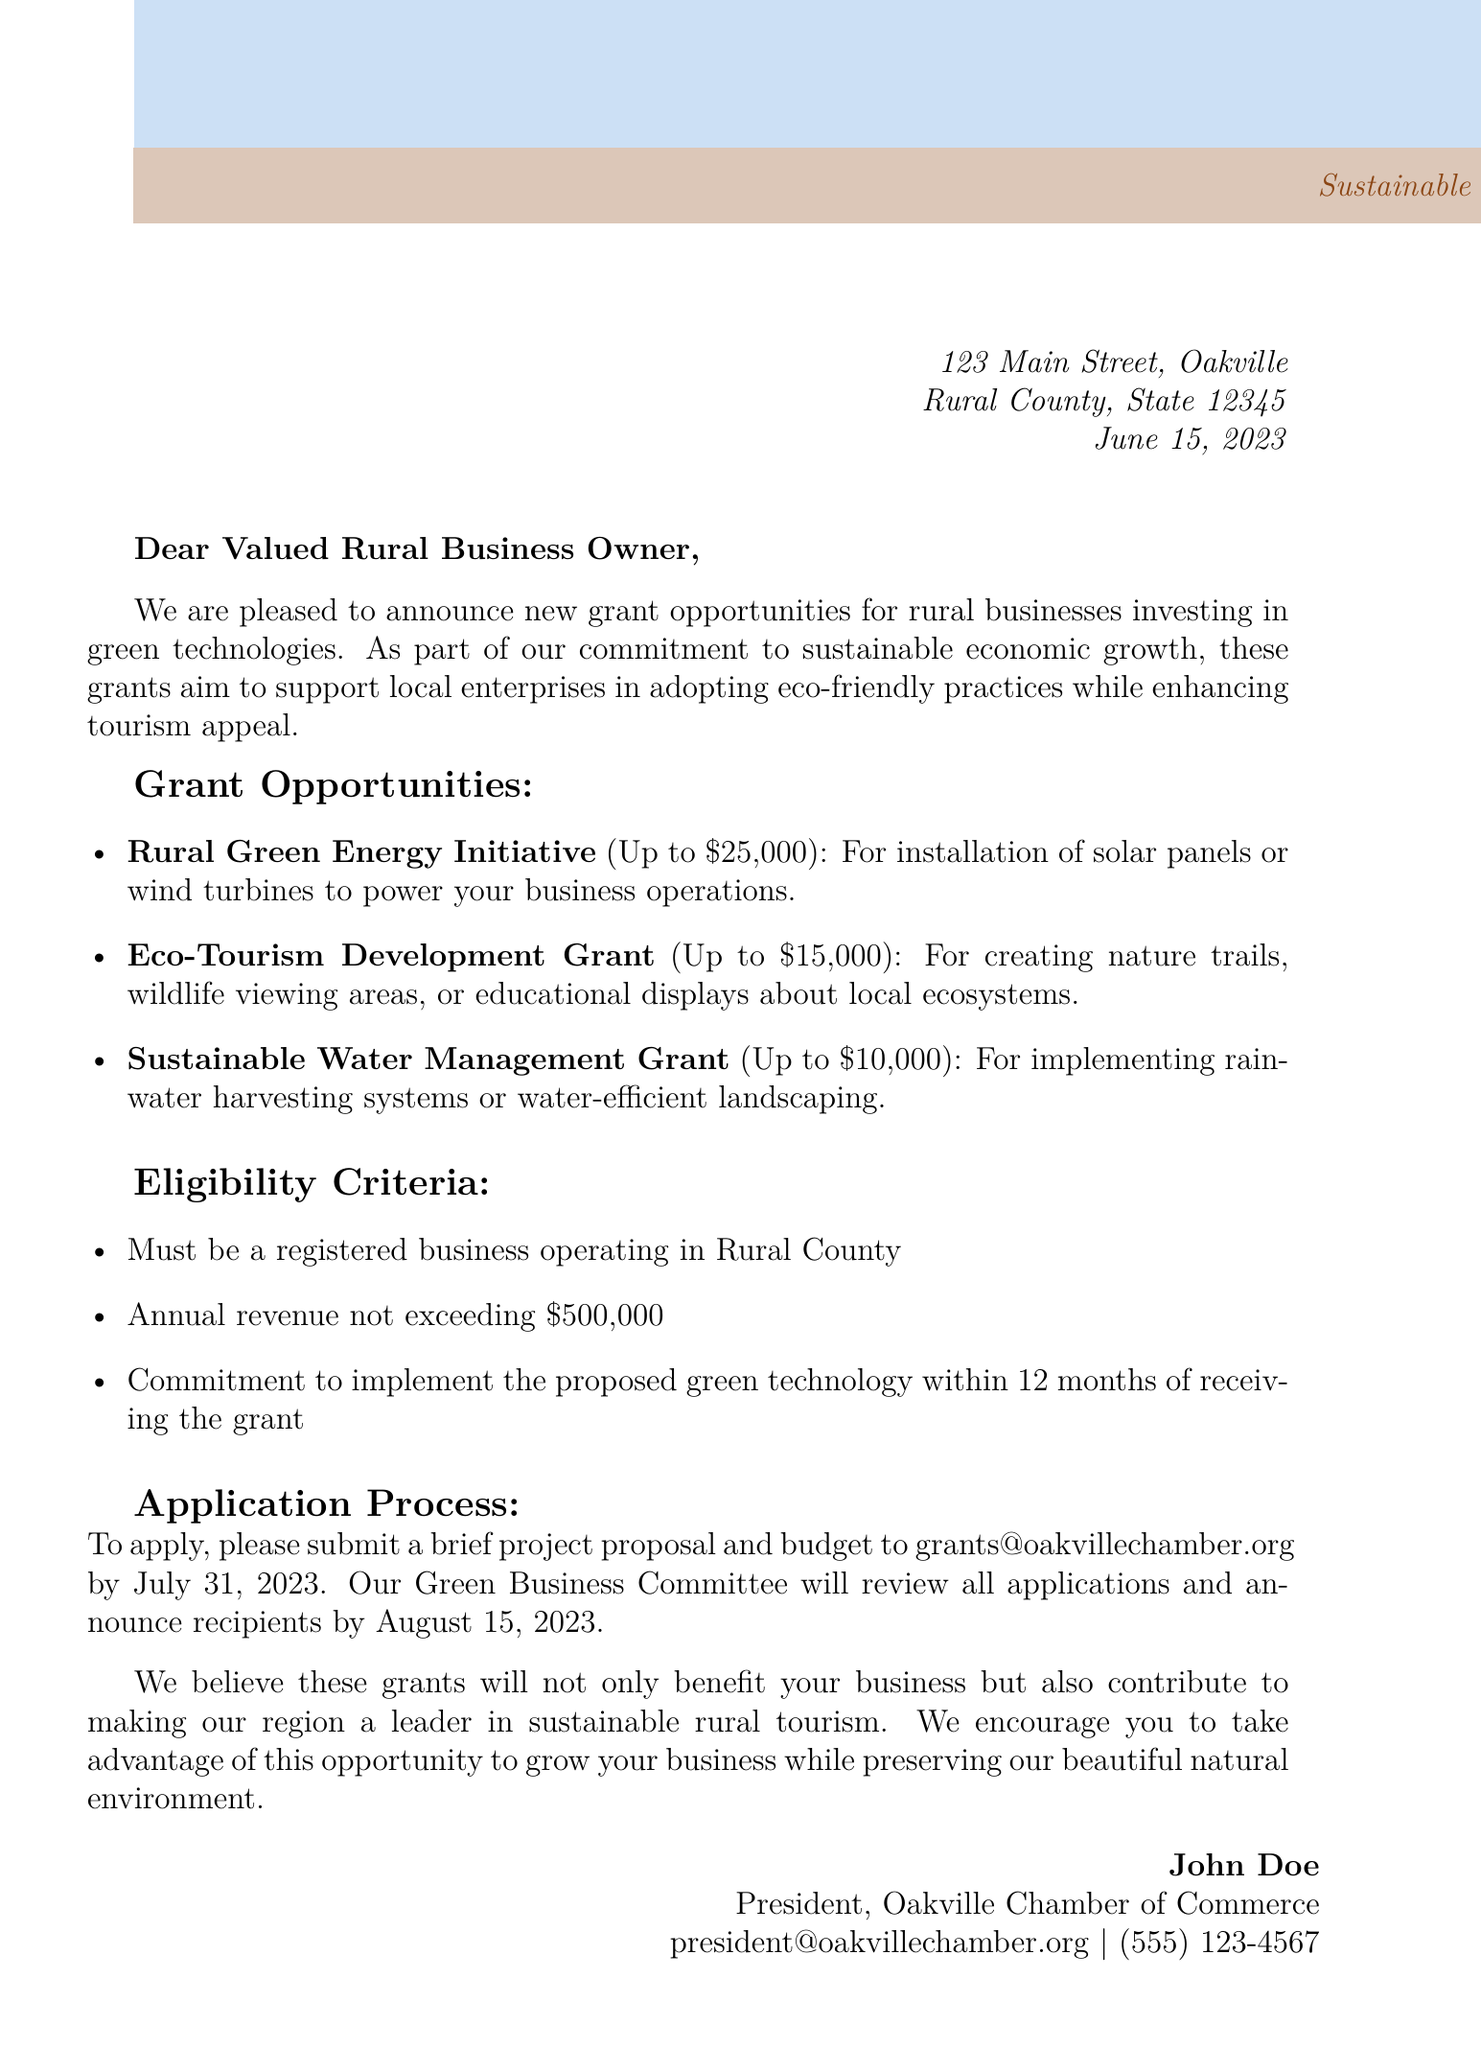what is the name of the organization sending the letter? The organization sending the letter is identified at the top of the document.
Answer: Oakville Chamber of Commerce what is the date of the letter? The date is provided in the letter's header section.
Answer: June 15, 2023 what is the maximum amount for the Rural Green Energy Initiative grant? The letter specifies the maximum funding for this grant in the grant details section.
Answer: Up to $25,000 what is one type of project eligible for the Eco-Tourism Development Grant? The letter provides several examples of projects eligible for this grant.
Answer: Creating nature trails what are the eligibility criteria regarding annual revenue? The letter outlines specific eligibility criteria, including a revenue limit.
Answer: Not exceeding $500,000 how will the recipients of the grants be announced? The letter details the process for announcing grant recipients.
Answer: By August 15, 2023 what is the application deadline for the grants? The application process section specifies the deadline for submitting proposals.
Answer: July 31, 2023 who is the signatory of the letter? The name of the signatory is found in the closing section of the letter.
Answer: John Doe what is the focus of the grants mentioned in the letter? The letter emphasizes the purpose of the grants at the start.
Answer: Green technologies 